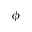<formula> <loc_0><loc_0><loc_500><loc_500>\phi</formula> 